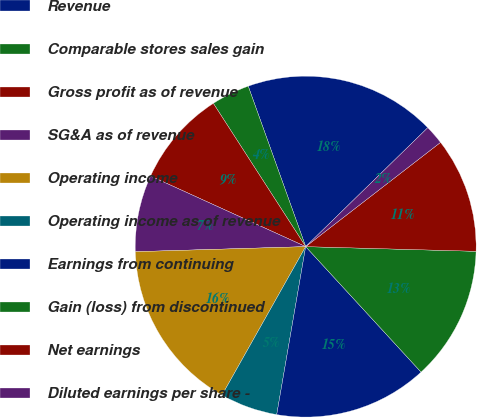<chart> <loc_0><loc_0><loc_500><loc_500><pie_chart><fcel>Revenue<fcel>Comparable stores sales gain<fcel>Gross profit as of revenue<fcel>SG&A as of revenue<fcel>Operating income<fcel>Operating income as of revenue<fcel>Earnings from continuing<fcel>Gain (loss) from discontinued<fcel>Net earnings<fcel>Diluted earnings per share -<nl><fcel>18.18%<fcel>3.64%<fcel>9.09%<fcel>7.27%<fcel>16.36%<fcel>5.45%<fcel>14.55%<fcel>12.73%<fcel>10.91%<fcel>1.82%<nl></chart> 